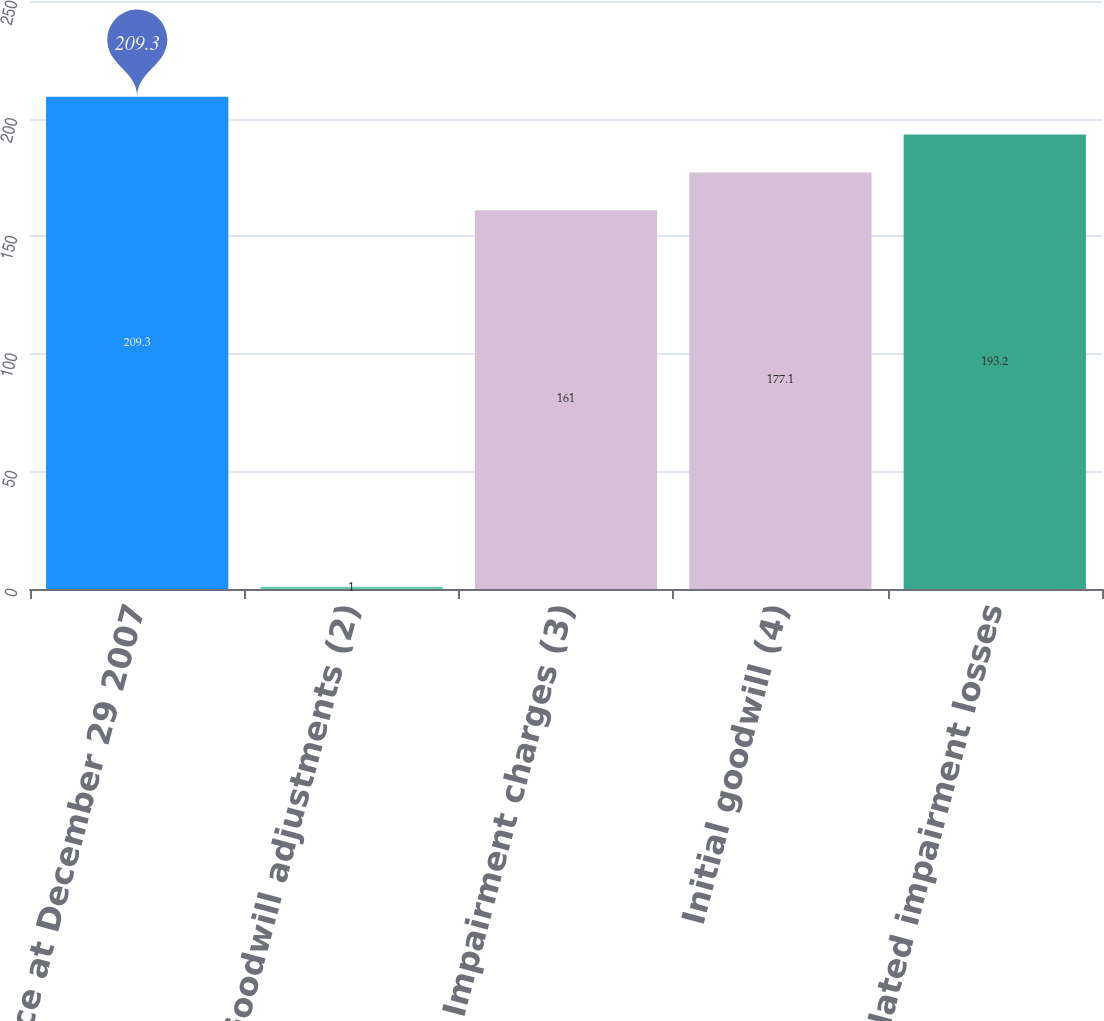<chart> <loc_0><loc_0><loc_500><loc_500><bar_chart><fcel>Balance at December 29 2007<fcel>Goodwill adjustments (2)<fcel>Impairment charges (3)<fcel>Initial goodwill (4)<fcel>Accumulated impairment losses<nl><fcel>209.3<fcel>1<fcel>161<fcel>177.1<fcel>193.2<nl></chart> 